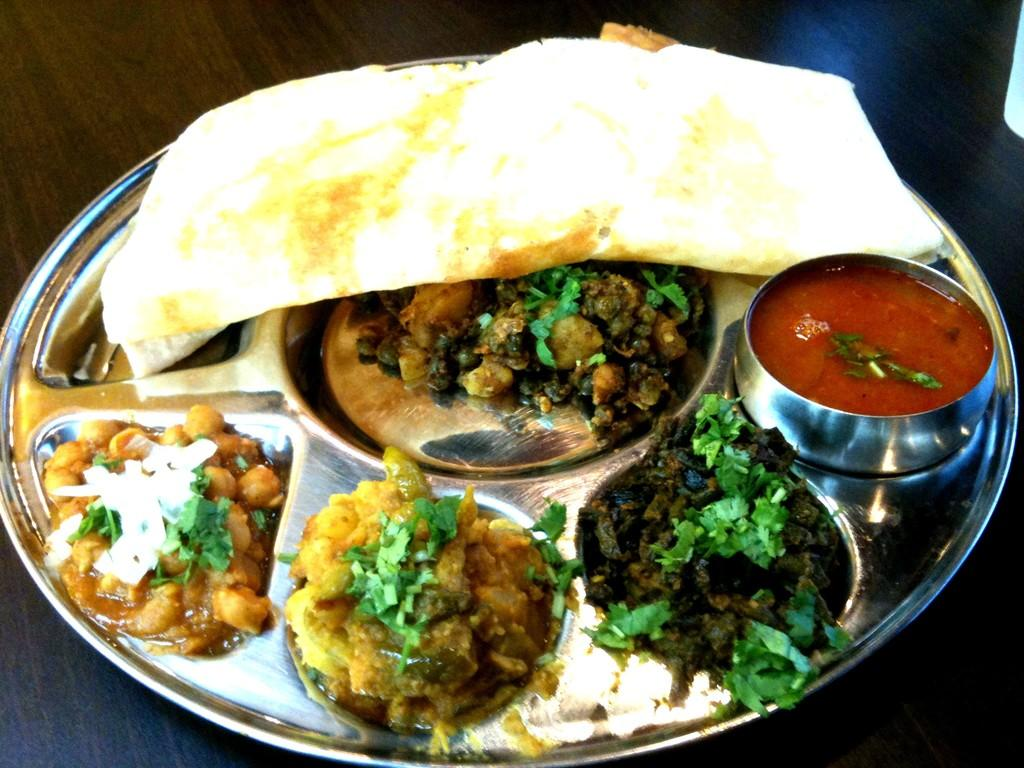What is present on the table in the image? There is a plate in the image. What is on the plate? The plate contains different food items. Where is the plate located? The plate is placed on a table. What type of brass instrument is being played in the image? There is no brass instrument or act of playing one present in the image; it only features a plate with food items on a table. 